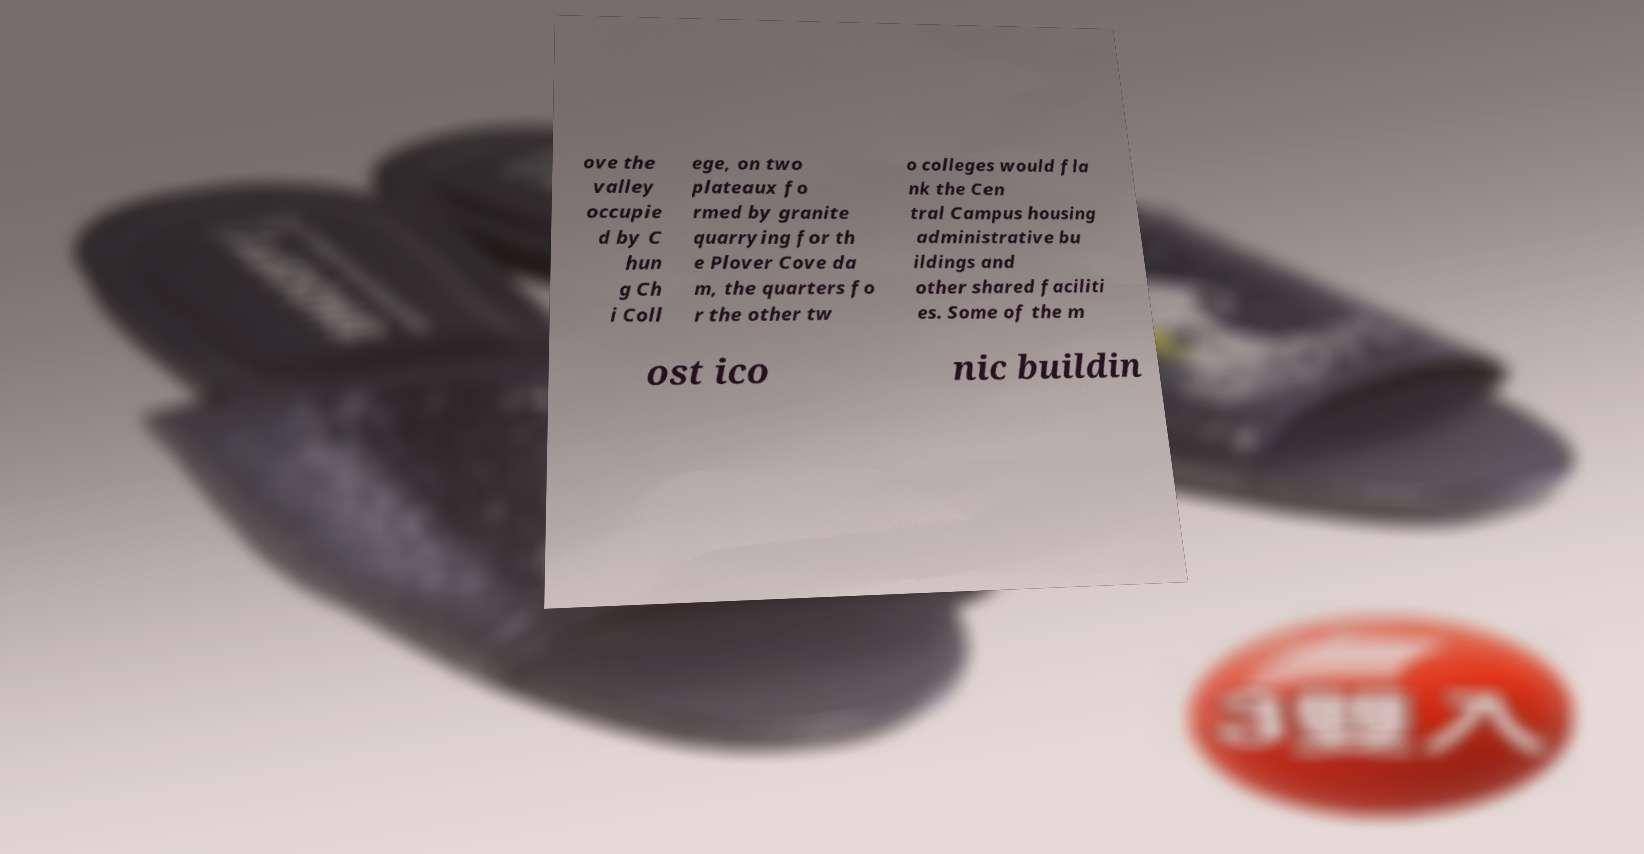For documentation purposes, I need the text within this image transcribed. Could you provide that? ove the valley occupie d by C hun g Ch i Coll ege, on two plateaux fo rmed by granite quarrying for th e Plover Cove da m, the quarters fo r the other tw o colleges would fla nk the Cen tral Campus housing administrative bu ildings and other shared faciliti es. Some of the m ost ico nic buildin 